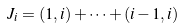<formula> <loc_0><loc_0><loc_500><loc_500>J _ { i } = ( 1 , i ) + \dots + ( i - 1 , i )</formula> 